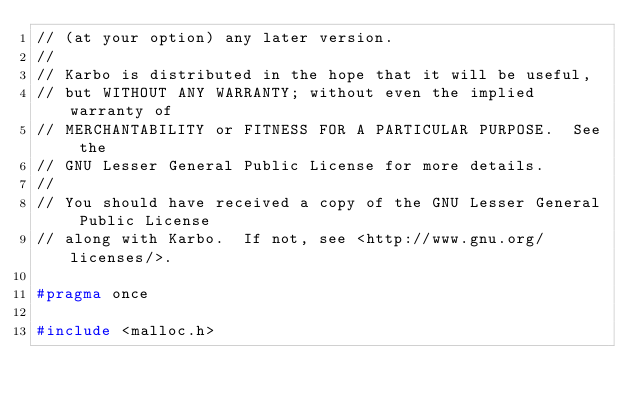Convert code to text. <code><loc_0><loc_0><loc_500><loc_500><_C_>// (at your option) any later version.
//
// Karbo is distributed in the hope that it will be useful,
// but WITHOUT ANY WARRANTY; without even the implied warranty of
// MERCHANTABILITY or FITNESS FOR A PARTICULAR PURPOSE.  See the
// GNU Lesser General Public License for more details.
//
// You should have received a copy of the GNU Lesser General Public License
// along with Karbo.  If not, see <http://www.gnu.org/licenses/>.

#pragma once

#include <malloc.h>
</code> 